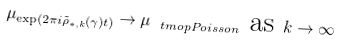Convert formula to latex. <formula><loc_0><loc_0><loc_500><loc_500>\mu _ { \exp ( 2 \pi i \tilde { \rho } _ { \ast , k } ( \gamma ) t ) } \rightarrow \mu _ { \ t m o p { P o i s s o n } } \text { as } k \rightarrow \infty</formula> 